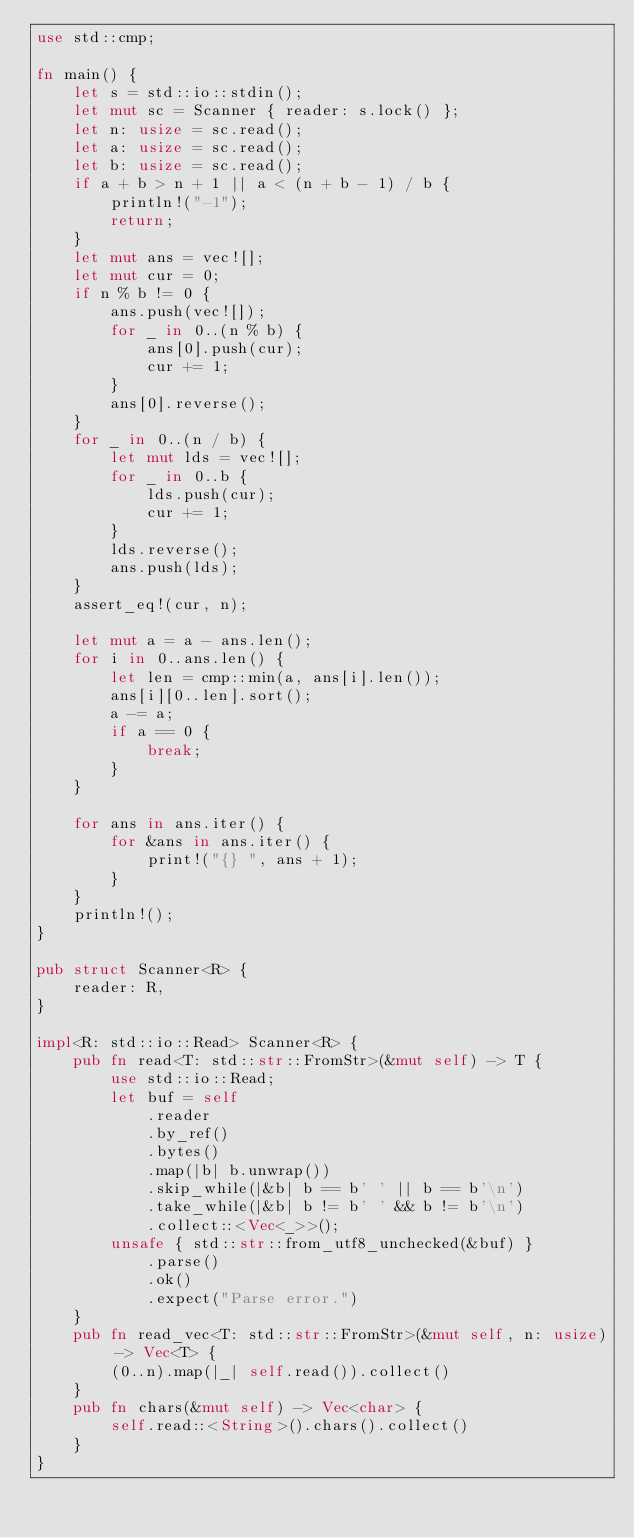<code> <loc_0><loc_0><loc_500><loc_500><_Rust_>use std::cmp;

fn main() {
    let s = std::io::stdin();
    let mut sc = Scanner { reader: s.lock() };
    let n: usize = sc.read();
    let a: usize = sc.read();
    let b: usize = sc.read();
    if a + b > n + 1 || a < (n + b - 1) / b {
        println!("-1");
        return;
    }
    let mut ans = vec![];
    let mut cur = 0;
    if n % b != 0 {
        ans.push(vec![]);
        for _ in 0..(n % b) {
            ans[0].push(cur);
            cur += 1;
        }
        ans[0].reverse();
    }
    for _ in 0..(n / b) {
        let mut lds = vec![];
        for _ in 0..b {
            lds.push(cur);
            cur += 1;
        }
        lds.reverse();
        ans.push(lds);
    }
    assert_eq!(cur, n);

    let mut a = a - ans.len();
    for i in 0..ans.len() {
        let len = cmp::min(a, ans[i].len());
        ans[i][0..len].sort();
        a -= a;
        if a == 0 {
            break;
        }
    }

    for ans in ans.iter() {
        for &ans in ans.iter() {
            print!("{} ", ans + 1);
        }
    }
    println!();
}

pub struct Scanner<R> {
    reader: R,
}

impl<R: std::io::Read> Scanner<R> {
    pub fn read<T: std::str::FromStr>(&mut self) -> T {
        use std::io::Read;
        let buf = self
            .reader
            .by_ref()
            .bytes()
            .map(|b| b.unwrap())
            .skip_while(|&b| b == b' ' || b == b'\n')
            .take_while(|&b| b != b' ' && b != b'\n')
            .collect::<Vec<_>>();
        unsafe { std::str::from_utf8_unchecked(&buf) }
            .parse()
            .ok()
            .expect("Parse error.")
    }
    pub fn read_vec<T: std::str::FromStr>(&mut self, n: usize) -> Vec<T> {
        (0..n).map(|_| self.read()).collect()
    }
    pub fn chars(&mut self) -> Vec<char> {
        self.read::<String>().chars().collect()
    }
}
</code> 